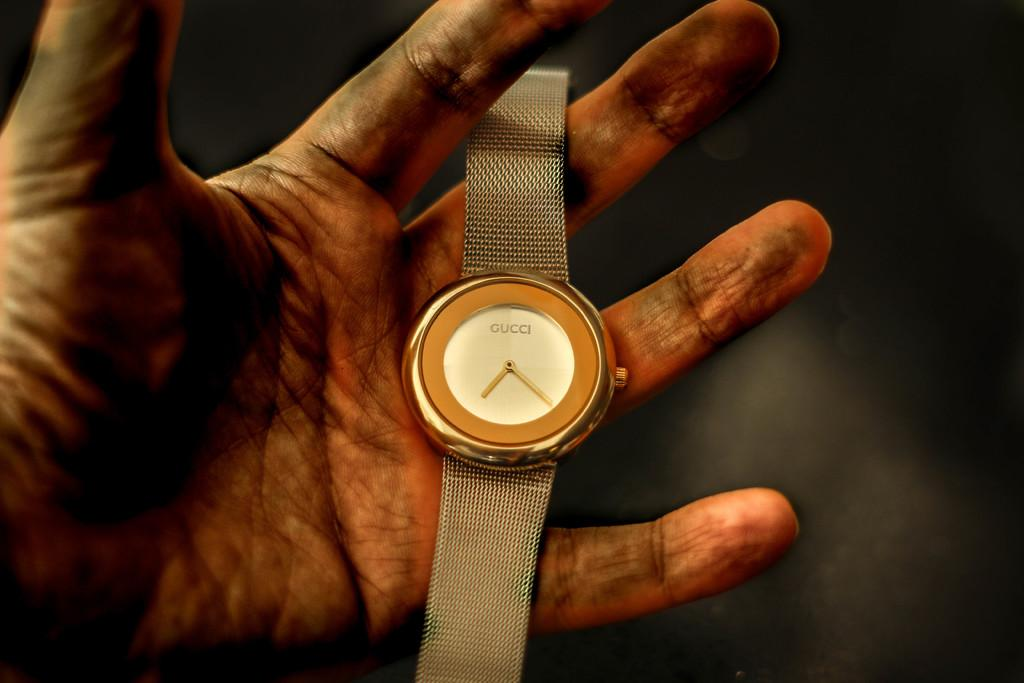<image>
Offer a succinct explanation of the picture presented. Person with dirty hands holding a wristwatch that says GUCCI on it. 